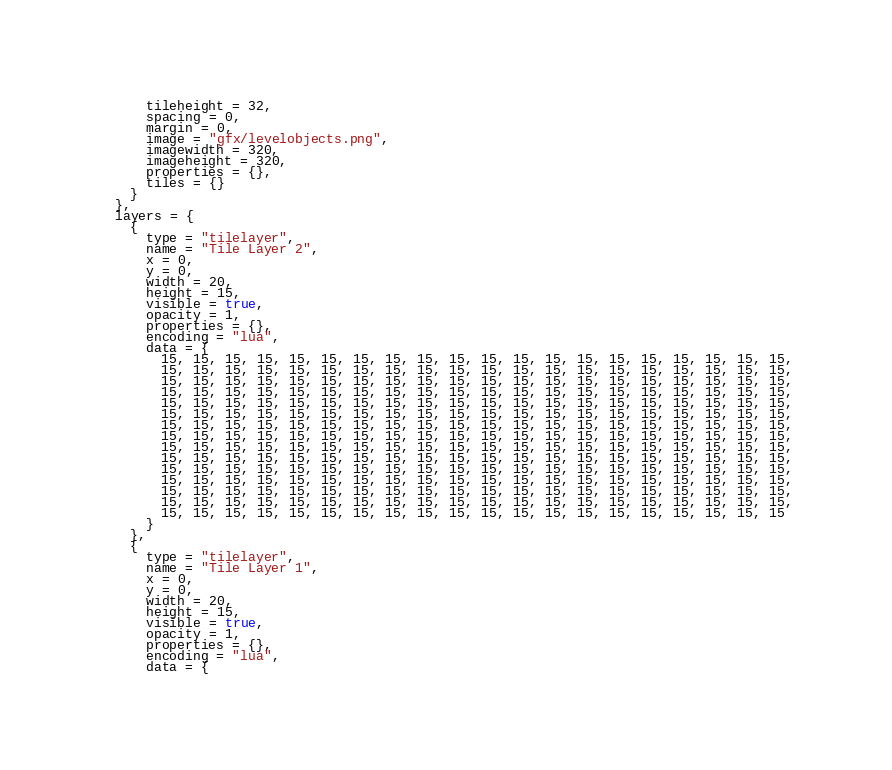Convert code to text. <code><loc_0><loc_0><loc_500><loc_500><_Lua_>      tileheight = 32,
      spacing = 0,
      margin = 0,
      image = "gfx/levelobjects.png",
      imagewidth = 320,
      imageheight = 320,
      properties = {},
      tiles = {}
    }
  },
  layers = {
    {
      type = "tilelayer",
      name = "Tile Layer 2",
      x = 0,
      y = 0,
      width = 20,
      height = 15,
      visible = true,
      opacity = 1,
      properties = {},
      encoding = "lua",
      data = {
        15, 15, 15, 15, 15, 15, 15, 15, 15, 15, 15, 15, 15, 15, 15, 15, 15, 15, 15, 15,
        15, 15, 15, 15, 15, 15, 15, 15, 15, 15, 15, 15, 15, 15, 15, 15, 15, 15, 15, 15,
        15, 15, 15, 15, 15, 15, 15, 15, 15, 15, 15, 15, 15, 15, 15, 15, 15, 15, 15, 15,
        15, 15, 15, 15, 15, 15, 15, 15, 15, 15, 15, 15, 15, 15, 15, 15, 15, 15, 15, 15,
        15, 15, 15, 15, 15, 15, 15, 15, 15, 15, 15, 15, 15, 15, 15, 15, 15, 15, 15, 15,
        15, 15, 15, 15, 15, 15, 15, 15, 15, 15, 15, 15, 15, 15, 15, 15, 15, 15, 15, 15,
        15, 15, 15, 15, 15, 15, 15, 15, 15, 15, 15, 15, 15, 15, 15, 15, 15, 15, 15, 15,
        15, 15, 15, 15, 15, 15, 15, 15, 15, 15, 15, 15, 15, 15, 15, 15, 15, 15, 15, 15,
        15, 15, 15, 15, 15, 15, 15, 15, 15, 15, 15, 15, 15, 15, 15, 15, 15, 15, 15, 15,
        15, 15, 15, 15, 15, 15, 15, 15, 15, 15, 15, 15, 15, 15, 15, 15, 15, 15, 15, 15,
        15, 15, 15, 15, 15, 15, 15, 15, 15, 15, 15, 15, 15, 15, 15, 15, 15, 15, 15, 15,
        15, 15, 15, 15, 15, 15, 15, 15, 15, 15, 15, 15, 15, 15, 15, 15, 15, 15, 15, 15,
        15, 15, 15, 15, 15, 15, 15, 15, 15, 15, 15, 15, 15, 15, 15, 15, 15, 15, 15, 15,
        15, 15, 15, 15, 15, 15, 15, 15, 15, 15, 15, 15, 15, 15, 15, 15, 15, 15, 15, 15,
        15, 15, 15, 15, 15, 15, 15, 15, 15, 15, 15, 15, 15, 15, 15, 15, 15, 15, 15, 15
      }
    },
    {
      type = "tilelayer",
      name = "Tile Layer 1",
      x = 0,
      y = 0,
      width = 20,
      height = 15,
      visible = true,
      opacity = 1,
      properties = {},
      encoding = "lua",
      data = {</code> 